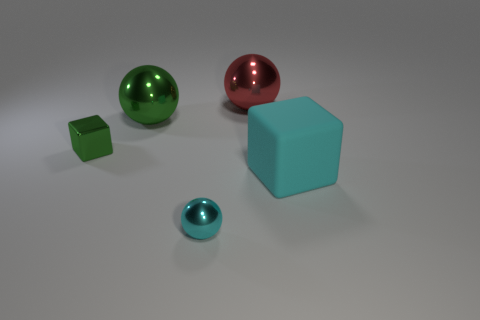Is there anything else that has the same material as the large cyan cube?
Your response must be concise. No. What number of other things are the same material as the cyan cube?
Ensure brevity in your answer.  0. Are there the same number of small metallic things to the left of the metal cube and blue balls?
Keep it short and to the point. Yes. Do the ball that is to the right of the cyan metallic ball and the cyan matte block have the same size?
Give a very brief answer. Yes. How many small shiny balls are in front of the green metal ball?
Ensure brevity in your answer.  1. There is a thing that is to the right of the green metallic sphere and left of the large red object; what material is it?
Provide a succinct answer. Metal. How many tiny things are red objects or green metal blocks?
Offer a terse response. 1. The red object is what size?
Your response must be concise. Large. There is a tiny cyan shiny object; what shape is it?
Make the answer very short. Sphere. Is there any other thing that is the same shape as the big cyan matte object?
Ensure brevity in your answer.  Yes. 